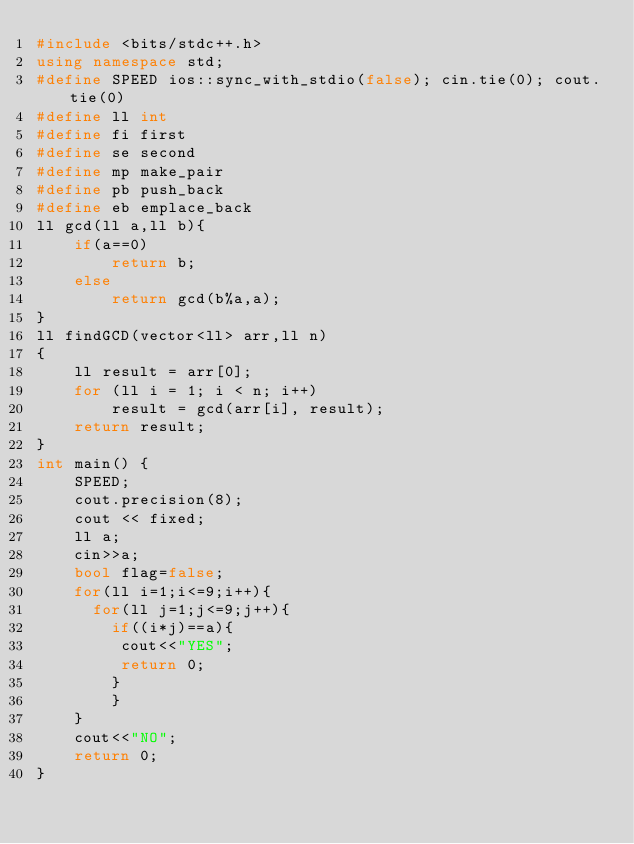<code> <loc_0><loc_0><loc_500><loc_500><_C++_>#include <bits/stdc++.h>
using namespace std;
#define SPEED ios::sync_with_stdio(false); cin.tie(0); cout.tie(0)
#define ll int
#define fi first
#define se second
#define mp make_pair
#define pb push_back
#define eb emplace_back
ll gcd(ll a,ll b){
    if(a==0)
        return b;
    else
        return gcd(b%a,a);
}
ll findGCD(vector<ll> arr,ll n) 
{ 
    ll result = arr[0]; 
    for (ll i = 1; i < n; i++) 
        result = gcd(arr[i], result);
    return result; 
}
int main() {
    SPEED;
    cout.precision(8);
    cout << fixed;
    ll a;
    cin>>a;
  	bool flag=false;
  	for(ll i=1;i<=9;i++){
      for(ll j=1;j<=9;j++){
      	if((i*j)==a){
         cout<<"YES";
         return 0;
        }
        }
    }
    cout<<"NO";
    return 0;
}
</code> 